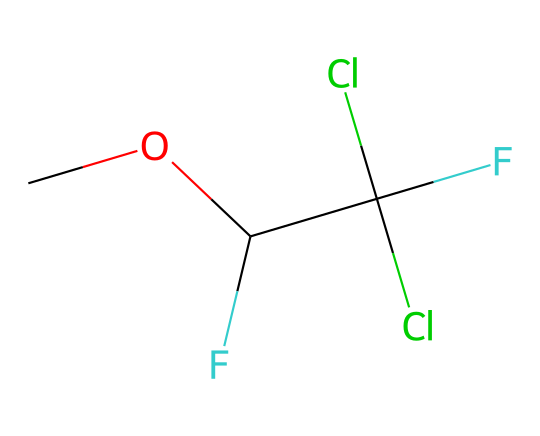How many carbon atoms are present in the molecular structure? From the SMILES representation, we can identify the carbon atoms. There are three distinct carbon symbols in the structure: one in the methoxy group (CO) and two in the carbon center (C(C(Cl)(Cl)F)F). Therefore, the total number of carbon atoms is three.
Answer: 3 What type of functional group is present in methoxyflurane? The presence of an ether functional group can be identified by the -O- bond connecting the methoxy (-OCH3) and the rest of the molecule. Ethers are characterized by the general structure R-O-R'.
Answer: ether What is the total number of fluorine atoms in the structure? The SMILES shows two fluorine atoms (F) indicated by the symbols. They are attached to the carbon center (C) in the molecular structure as represented.
Answer: 2 Which part of the structure suggests its use as a volatile anesthetic? The presence of the ether functional group (methoxy) is significant because ethers such as methoxyflurane are commonly used as volatile anesthetics due to their low blood solubility which allows for rapid induction and recovery.
Answer: ether functional group What is the total number of chlorine atoms in the structure? Looking at the SMILES representation, there are two chlorine atoms (Cl), both of which are attached to the same carbon atom in the structure (C(Cl)(Cl)F).
Answer: 2 What is the molecular formula for methoxyflurane based on its structure? To determine the molecular formula, we count the atoms represented in the structure: 3 carbon (C), 3 hydrogen (H), 2 fluorine (F), and 2 chlorine (Cl), resulting in the formula C3H3Cl2F2O.
Answer: C3H3Cl2F2O 